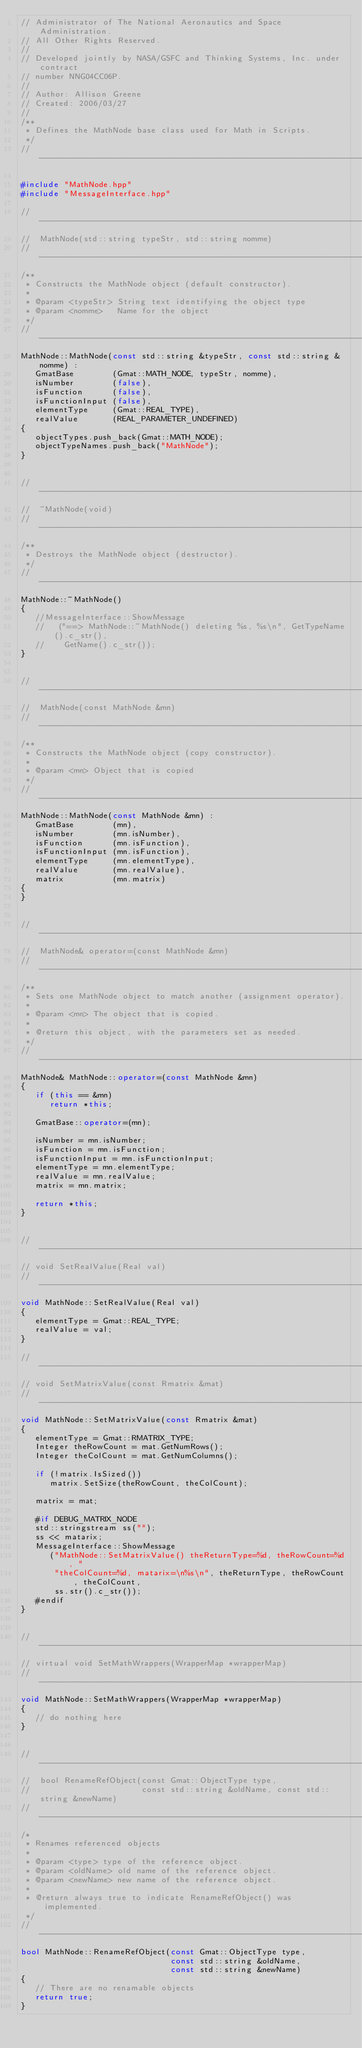Convert code to text. <code><loc_0><loc_0><loc_500><loc_500><_C++_>// Administrator of The National Aeronautics and Space Administration.
// All Other Rights Reserved.
//
// Developed jointly by NASA/GSFC and Thinking Systems, Inc. under contract
// number NNG04CC06P.
//
// Author: Allison Greene
// Created: 2006/03/27
//
/**
 * Defines the MathNode base class used for Math in Scripts.
 */
//------------------------------------------------------------------------------

#include "MathNode.hpp"
#include "MessageInterface.hpp"

//------------------------------------------------------------------------------
//  MathNode(std::string typeStr, std::string nomme)
//------------------------------------------------------------------------------
/**
 * Constructs the MathNode object (default constructor).
 * 
 * @param <typeStr> String text identifying the object type
 * @param <nomme>   Name for the object
 */
//------------------------------------------------------------------------------
MathNode::MathNode(const std::string &typeStr, const std::string &nomme) :
   GmatBase        (Gmat::MATH_NODE, typeStr, nomme),
   isNumber        (false),
   isFunction      (false),
   isFunctionInput (false),
   elementType     (Gmat::REAL_TYPE),
   realValue       (REAL_PARAMETER_UNDEFINED)
{
   objectTypes.push_back(Gmat::MATH_NODE);
   objectTypeNames.push_back("MathNode");   
}


//------------------------------------------------------------------------------
//  ~MathNode(void)
//------------------------------------------------------------------------------
/**
 * Destroys the MathNode object (destructor).
 */
//------------------------------------------------------------------------------
MathNode::~MathNode()
{
   //MessageInterface::ShowMessage
   //   ("==> MathNode::~MathNode() deleting %s, %s\n", GetTypeName().c_str(),
   //    GetName().c_str());
}


//------------------------------------------------------------------------------
//  MathNode(const MathNode &mn)
//------------------------------------------------------------------------------
/**
 * Constructs the MathNode object (copy constructor).
 * 
 * @param <mn> Object that is copied
 */
//------------------------------------------------------------------------------
MathNode::MathNode(const MathNode &mn) :
   GmatBase        (mn),
   isNumber        (mn.isNumber),
   isFunction      (mn.isFunction),
   isFunctionInput (mn.isFunction),
   elementType     (mn.elementType),
   realValue       (mn.realValue),
   matrix          (mn.matrix)
{
}


//------------------------------------------------------------------------------
//  MathNode& operator=(const MathNode &mn)
//------------------------------------------------------------------------------
/**
 * Sets one MathNode object to match another (assignment operator).
 * 
 * @param <mn> The object that is copied.
 * 
 * @return this object, with the parameters set as needed.
 */
//------------------------------------------------------------------------------
MathNode& MathNode::operator=(const MathNode &mn)
{
   if (this == &mn)
      return *this;
   
   GmatBase::operator=(mn);
   
   isNumber = mn.isNumber;
   isFunction = mn.isFunction;
   isFunctionInput = mn.isFunctionInput;
   elementType = mn.elementType;
   realValue = mn.realValue;
   matrix = mn.matrix;
   
   return *this;
}


//------------------------------------------------------------------------------
// void SetRealValue(Real val)
//------------------------------------------------------------------------------
void MathNode::SetRealValue(Real val)
{
   elementType = Gmat::REAL_TYPE;
   realValue = val;
}

//------------------------------------------------------------------------------
// void SetMatrixValue(const Rmatrix &mat)
//------------------------------------------------------------------------------
void MathNode::SetMatrixValue(const Rmatrix &mat)
{
   elementType = Gmat::RMATRIX_TYPE;
   Integer theRowCount = mat.GetNumRows();
   Integer theColCount = mat.GetNumColumns();
   
   if (!matrix.IsSized())
      matrix.SetSize(theRowCount, theColCount);
   
   matrix = mat;
   
   #if DEBUG_MATRIX_NODE
   std::stringstream ss("");
   ss << matarix;
   MessageInterface::ShowMessage
      ("MathNode::SetMatrixValue() theReturnType=%d, theRowCount=%d, "
       "theColCount=%d, matarix=\n%s\n", theReturnType, theRowCount, theColCount,
       ss.str().c_str());
   #endif
}


//---------------------------------------------------------------------------
// virtual void SetMathWrappers(WrapperMap *wrapperMap)
//---------------------------------------------------------------------------
void MathNode::SetMathWrappers(WrapperMap *wrapperMap)
{
   // do nothing here
}


//---------------------------------------------------------------------------
//  bool RenameRefObject(const Gmat::ObjectType type,
//                       const std::string &oldName, const std::string &newName)
//---------------------------------------------------------------------------
/*
 * Renames referenced objects
 *
 * @param <type> type of the reference object.
 * @param <oldName> old name of the reference object.
 * @param <newName> new name of the reference object.
 *
 * @return always true to indicate RenameRefObject() was implemented.
 */
//---------------------------------------------------------------------------
bool MathNode::RenameRefObject(const Gmat::ObjectType type,
                               const std::string &oldName,
                               const std::string &newName)
{
   // There are no renamable objects
   return true;
}

</code> 